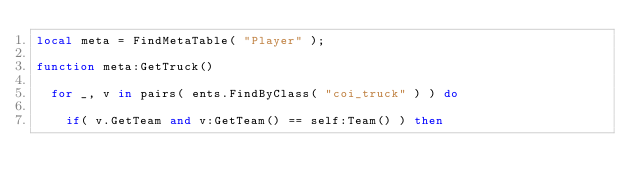Convert code to text. <code><loc_0><loc_0><loc_500><loc_500><_Lua_>local meta = FindMetaTable( "Player" );

function meta:GetTruck()

	for _, v in pairs( ents.FindByClass( "coi_truck" ) ) do

		if( v.GetTeam and v:GetTeam() == self:Team() ) then
</code> 